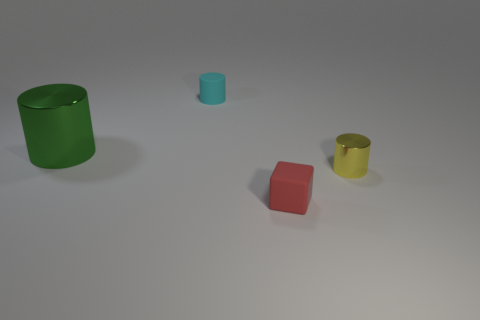Does the small red block have the same material as the cyan cylinder?
Your answer should be very brief. Yes. What is the size of the yellow object that is the same shape as the cyan object?
Your response must be concise. Small. There is a metallic object that is behind the small yellow metal cylinder; does it have the same shape as the tiny thing that is behind the large green thing?
Provide a succinct answer. Yes. Do the green metal cylinder and the shiny cylinder that is on the right side of the small cyan thing have the same size?
Offer a very short reply. No. What number of other objects are there of the same material as the cyan thing?
Your answer should be compact. 1. Is there any other thing that has the same shape as the big thing?
Offer a very short reply. Yes. What color is the cylinder that is on the right side of the small cylinder that is left of the rubber thing in front of the small shiny object?
Provide a succinct answer. Yellow. What is the shape of the small thing that is both in front of the cyan rubber cylinder and behind the matte block?
Offer a terse response. Cylinder. Is there any other thing that has the same size as the green cylinder?
Your answer should be very brief. No. What color is the object that is right of the small rubber thing in front of the big green thing?
Offer a terse response. Yellow. 